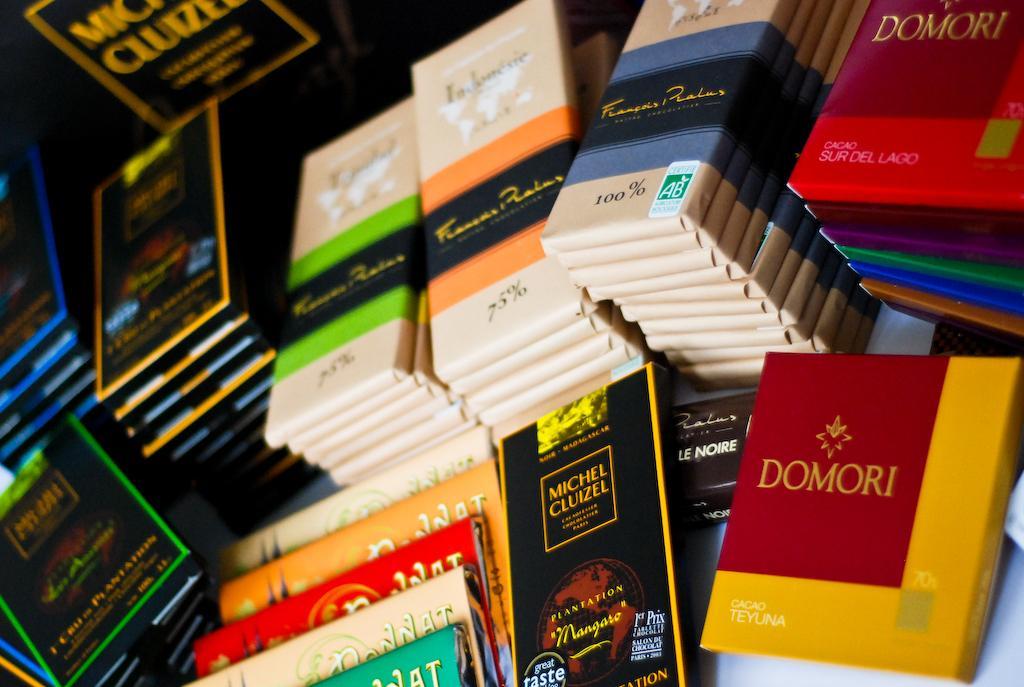Can you describe this image briefly? In this picture I can see there are few objects placed on the table and they are packed in different colored wrappers. 